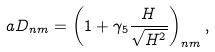Convert formula to latex. <formula><loc_0><loc_0><loc_500><loc_500>a D _ { n m } = \left ( 1 + \gamma _ { 5 } \frac { H } { \sqrt { H ^ { 2 } } } \right ) _ { n m } ,</formula> 